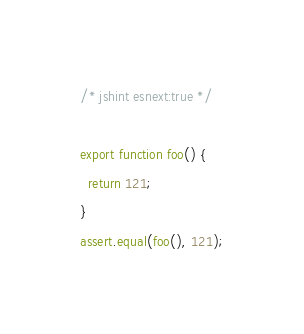<code> <loc_0><loc_0><loc_500><loc_500><_JavaScript_>/* jshint esnext:true */

export function foo() {
  return 121;
}
assert.equal(foo(), 121);
</code> 